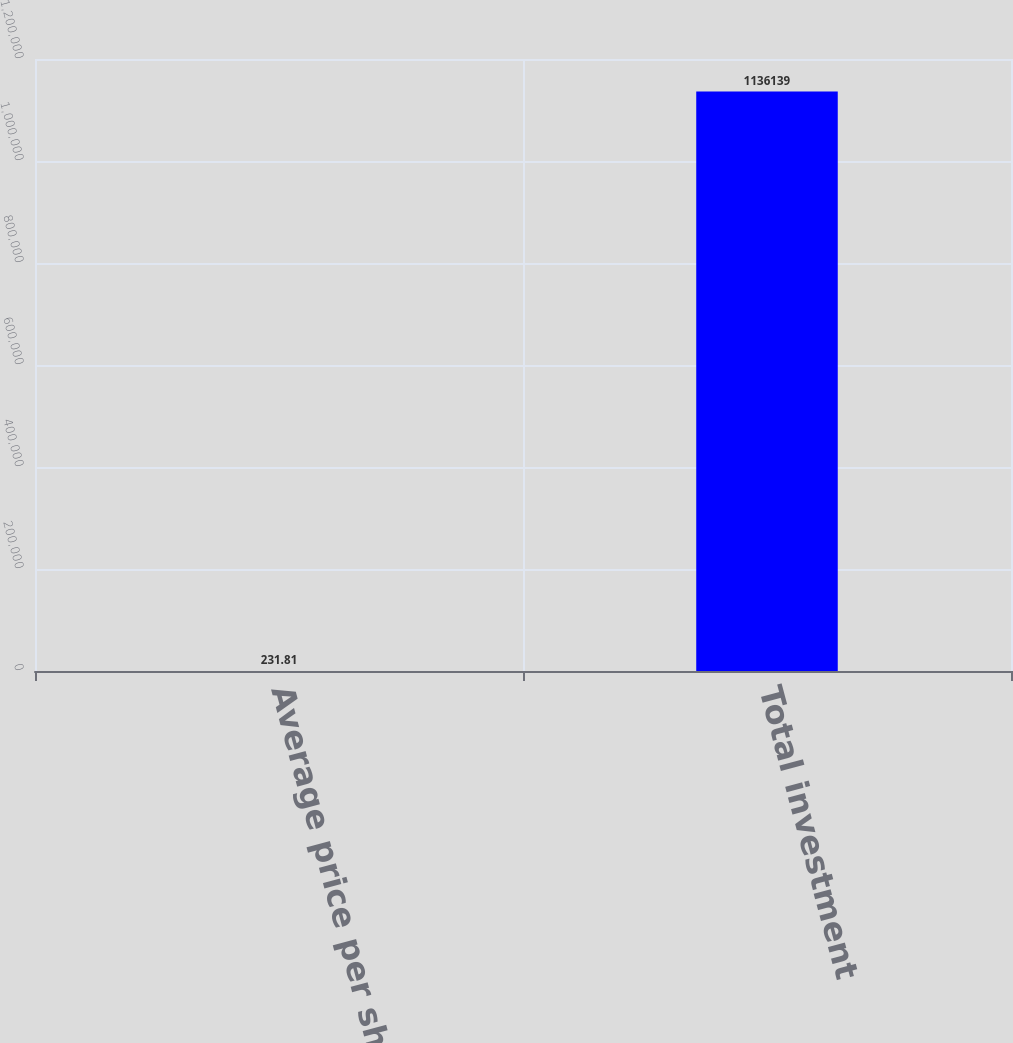Convert chart. <chart><loc_0><loc_0><loc_500><loc_500><bar_chart><fcel>Average price per share<fcel>Total investment<nl><fcel>231.81<fcel>1.13614e+06<nl></chart> 